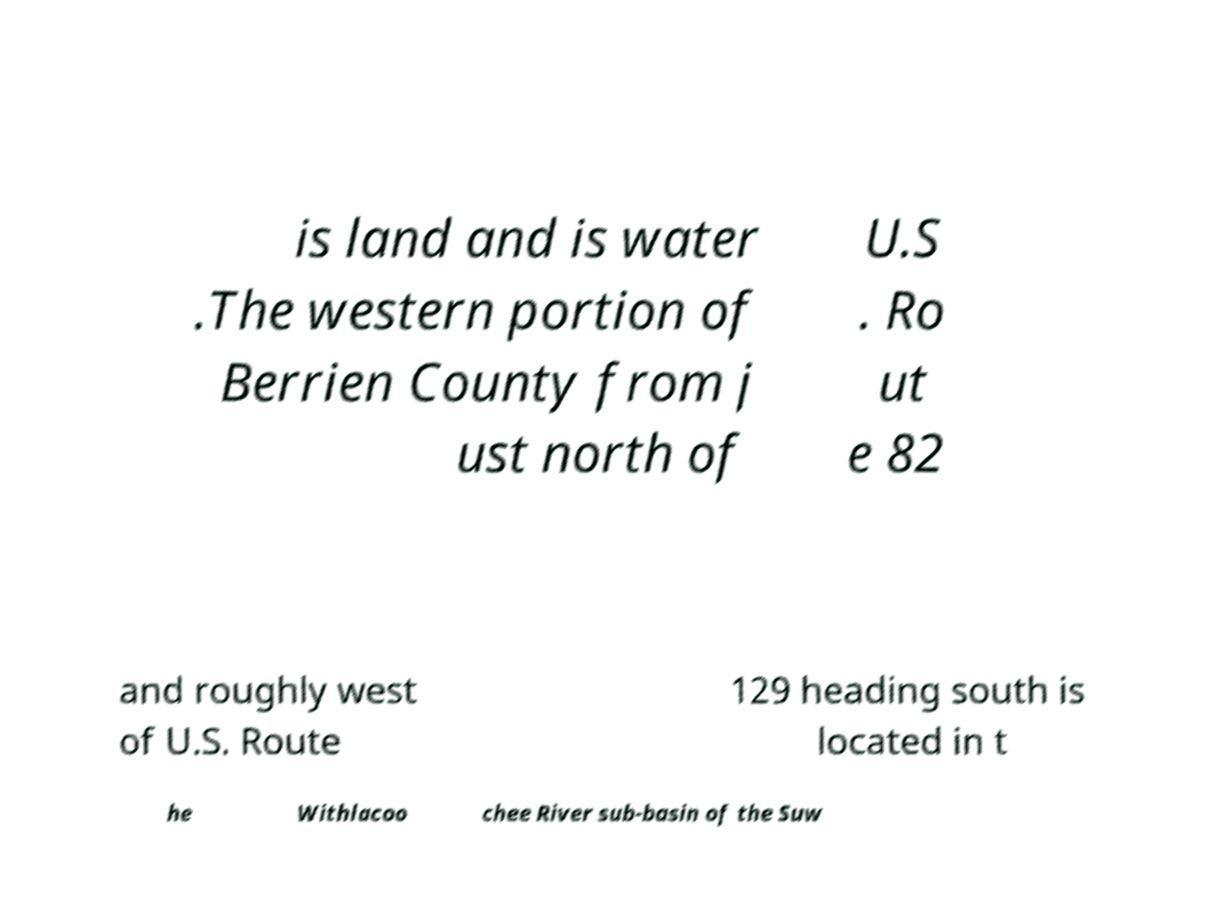Could you extract and type out the text from this image? is land and is water .The western portion of Berrien County from j ust north of U.S . Ro ut e 82 and roughly west of U.S. Route 129 heading south is located in t he Withlacoo chee River sub-basin of the Suw 